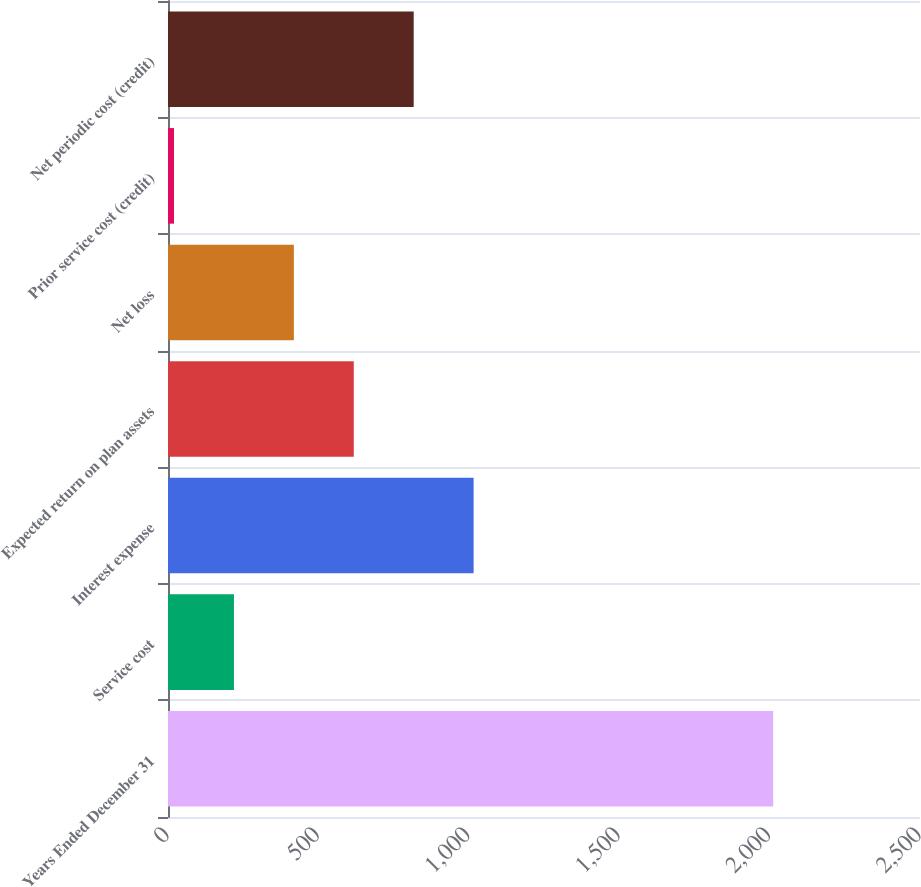Convert chart to OTSL. <chart><loc_0><loc_0><loc_500><loc_500><bar_chart><fcel>Years Ended December 31<fcel>Service cost<fcel>Interest expense<fcel>Expected return on plan assets<fcel>Net loss<fcel>Prior service cost (credit)<fcel>Net periodic cost (credit)<nl><fcel>2012<fcel>219.2<fcel>1016<fcel>617.6<fcel>418.4<fcel>20<fcel>816.8<nl></chart> 